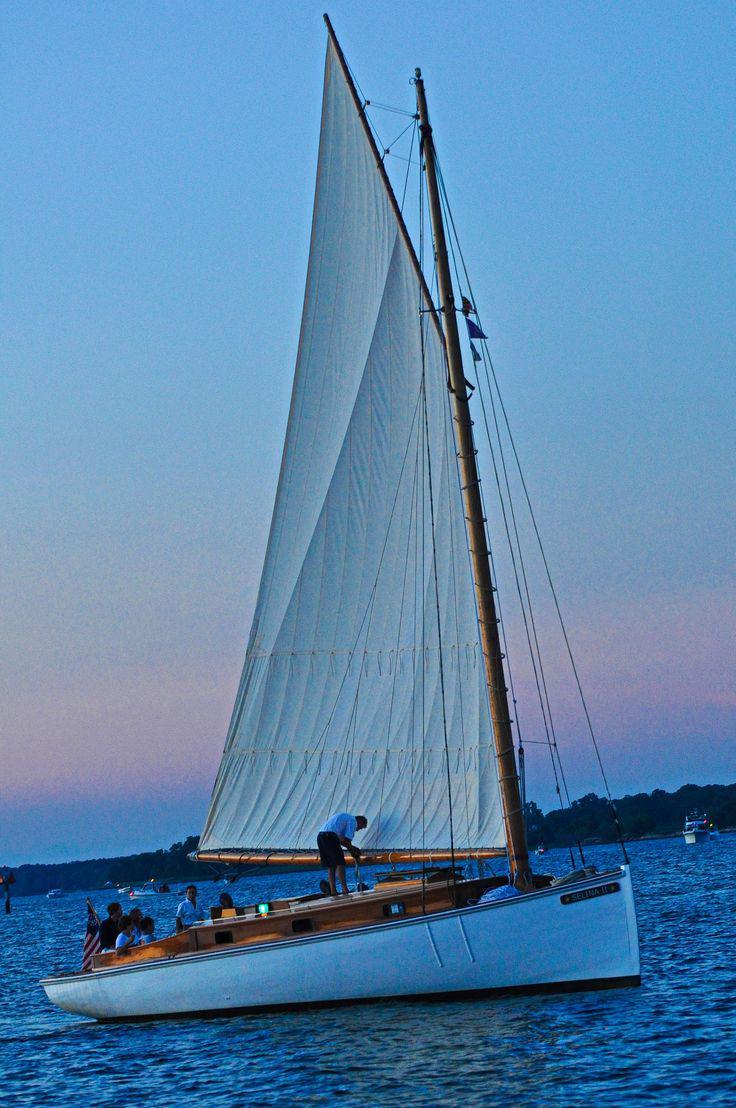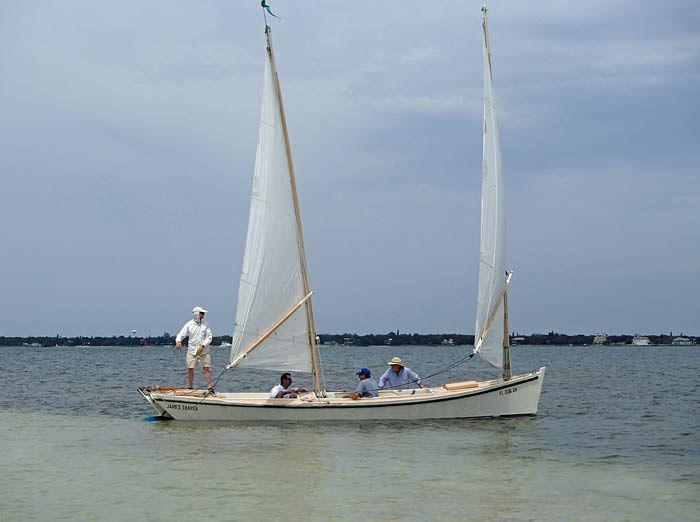The first image is the image on the left, the second image is the image on the right. For the images shown, is this caption "There is a sailboat with only two distinct sails." true? Answer yes or no. Yes. 